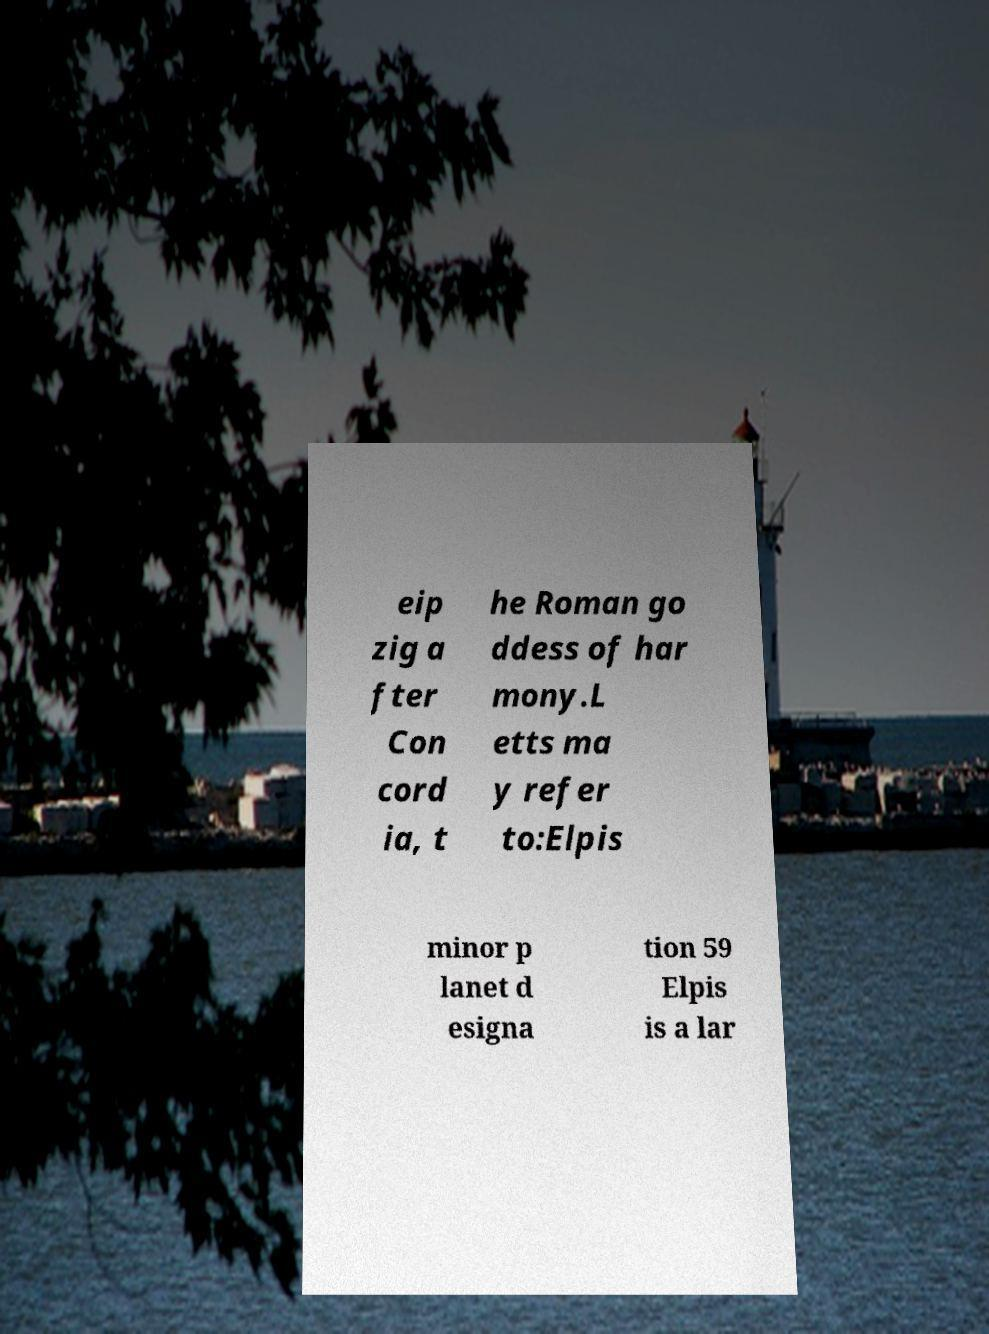Please identify and transcribe the text found in this image. eip zig a fter Con cord ia, t he Roman go ddess of har mony.L etts ma y refer to:Elpis minor p lanet d esigna tion 59 Elpis is a lar 